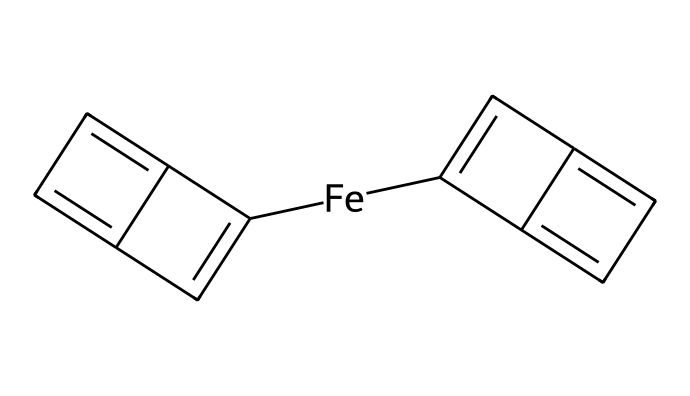What is the central metal atom in ferrocene? The chemical structure shows a single iron atom ([Fe]) at the center, surrounded by two cyclopentadienyl rings.
Answer: iron How many carbon atoms are present in the structure of ferrocene? The cyclopentadienyl rings each contain five carbon atoms, giving a total of ten carbon atoms in the structure.
Answer: ten What type of coordination does ferrocene exhibit? The structure depicts a sandwich-like arrangement where iron is coordinated between two π-acceptor cyclopentadienyl ligands in a parallel fashion.
Answer: sandwich coordination What is the hybridization of the iron atom in ferrocene? The iron atom in ferrocene demonstrates a unique hybridization of sp², involved in bond formation with the cyclopentadienyl rings.
Answer: sp² How many π-bonds are formed by the cyclopentadienyl rings in ferrocene? Each cyclopentadienyl ring engages in five π-bonds, leading to a total of five π-bonds from both rings in the entire structure.
Answer: five What is the significance of the sandwich structure in organometallics like ferrocene? The sandwich structure is significant because it stabilizes the metal center, facilitating unique electronic properties useful in electronic materials.
Answer: stabilization How does the structure of ferrocene affect its reactivity as an organometallic compound? The electronic distribution due to the sandwich architecture allows ferrocene to participate in electrophilic attacks while being relatively stable, impacting its reactivity.
Answer: stability 